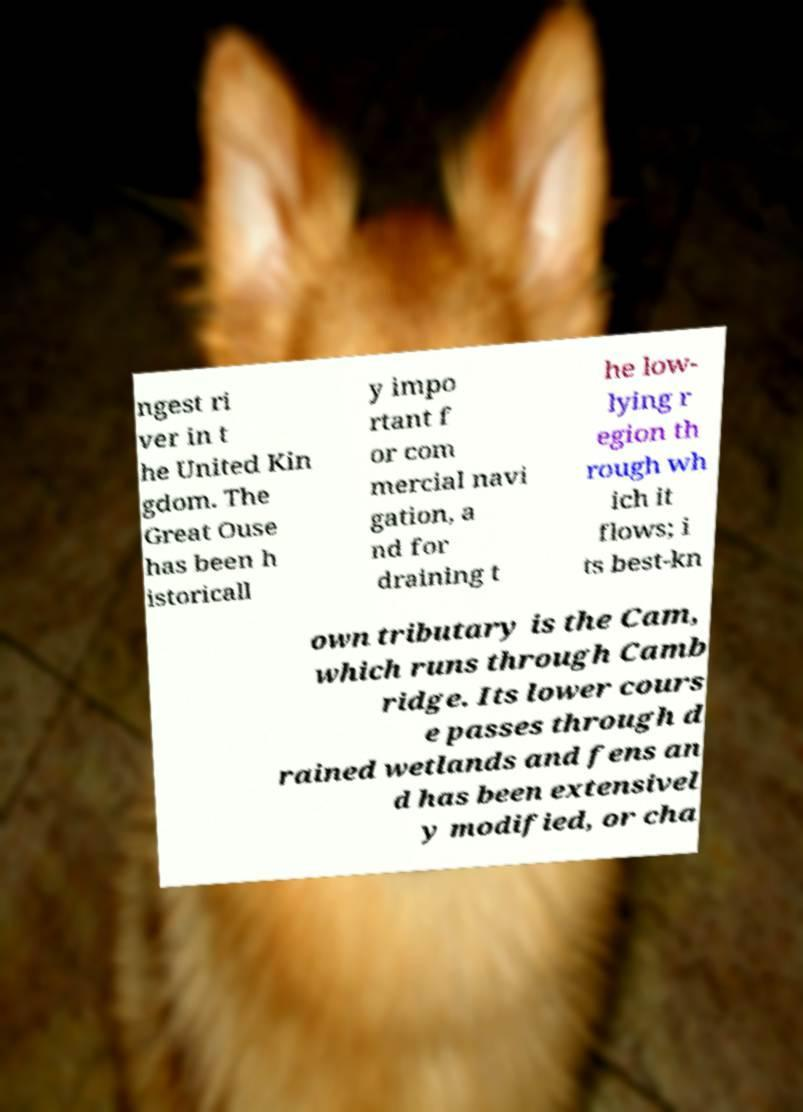There's text embedded in this image that I need extracted. Can you transcribe it verbatim? ngest ri ver in t he United Kin gdom. The Great Ouse has been h istoricall y impo rtant f or com mercial navi gation, a nd for draining t he low- lying r egion th rough wh ich it flows; i ts best-kn own tributary is the Cam, which runs through Camb ridge. Its lower cours e passes through d rained wetlands and fens an d has been extensivel y modified, or cha 